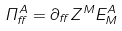<formula> <loc_0><loc_0><loc_500><loc_500>\Pi _ { \alpha } ^ { A } = \partial _ { \alpha } Z ^ { M } E ^ { A } _ { M }</formula> 